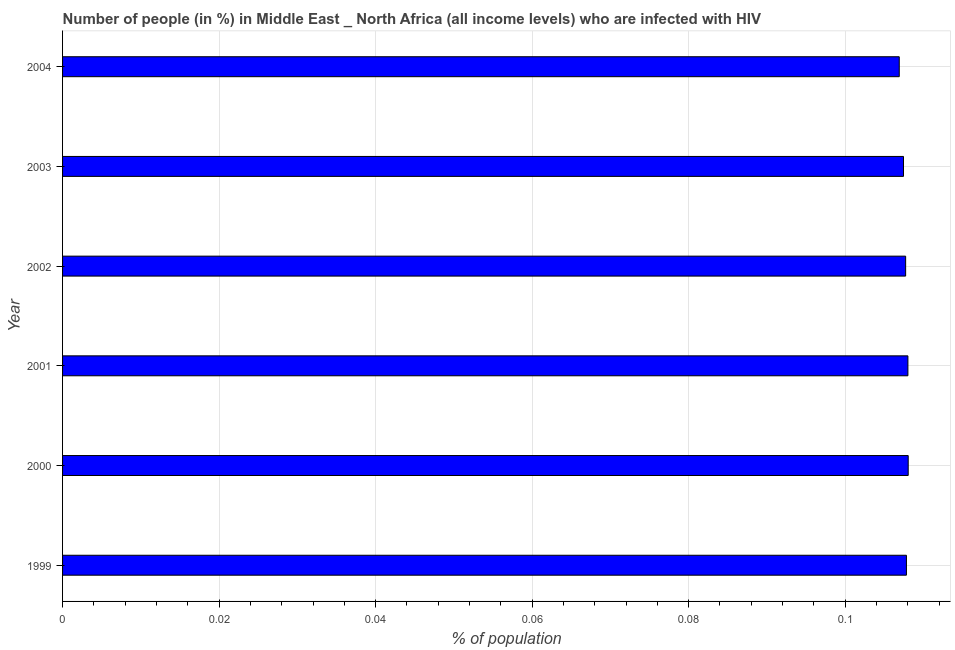Does the graph contain grids?
Offer a terse response. Yes. What is the title of the graph?
Ensure brevity in your answer.  Number of people (in %) in Middle East _ North Africa (all income levels) who are infected with HIV. What is the label or title of the X-axis?
Your response must be concise. % of population. What is the number of people infected with hiv in 2001?
Provide a short and direct response. 0.11. Across all years, what is the maximum number of people infected with hiv?
Your answer should be very brief. 0.11. Across all years, what is the minimum number of people infected with hiv?
Make the answer very short. 0.11. What is the sum of the number of people infected with hiv?
Make the answer very short. 0.65. What is the average number of people infected with hiv per year?
Keep it short and to the point. 0.11. What is the median number of people infected with hiv?
Provide a short and direct response. 0.11. In how many years, is the number of people infected with hiv greater than 0.06 %?
Provide a short and direct response. 6. What is the ratio of the number of people infected with hiv in 1999 to that in 2003?
Your answer should be very brief. 1. What is the difference between the highest and the second highest number of people infected with hiv?
Offer a terse response. 0. Is the sum of the number of people infected with hiv in 2001 and 2004 greater than the maximum number of people infected with hiv across all years?
Provide a short and direct response. Yes. In how many years, is the number of people infected with hiv greater than the average number of people infected with hiv taken over all years?
Offer a terse response. 4. How many bars are there?
Offer a very short reply. 6. How many years are there in the graph?
Ensure brevity in your answer.  6. What is the % of population of 1999?
Ensure brevity in your answer.  0.11. What is the % of population of 2000?
Provide a succinct answer. 0.11. What is the % of population of 2001?
Give a very brief answer. 0.11. What is the % of population in 2002?
Provide a succinct answer. 0.11. What is the % of population of 2003?
Offer a terse response. 0.11. What is the % of population of 2004?
Offer a terse response. 0.11. What is the difference between the % of population in 1999 and 2000?
Your response must be concise. -0. What is the difference between the % of population in 1999 and 2001?
Provide a short and direct response. -0. What is the difference between the % of population in 1999 and 2003?
Provide a succinct answer. 0. What is the difference between the % of population in 1999 and 2004?
Offer a terse response. 0. What is the difference between the % of population in 2000 and 2001?
Give a very brief answer. 4e-5. What is the difference between the % of population in 2000 and 2002?
Keep it short and to the point. 0. What is the difference between the % of population in 2000 and 2003?
Give a very brief answer. 0. What is the difference between the % of population in 2000 and 2004?
Offer a terse response. 0. What is the difference between the % of population in 2001 and 2002?
Give a very brief answer. 0. What is the difference between the % of population in 2001 and 2003?
Provide a succinct answer. 0. What is the difference between the % of population in 2001 and 2004?
Make the answer very short. 0. What is the difference between the % of population in 2002 and 2003?
Make the answer very short. 0. What is the difference between the % of population in 2002 and 2004?
Offer a very short reply. 0. What is the difference between the % of population in 2003 and 2004?
Offer a very short reply. 0. What is the ratio of the % of population in 1999 to that in 2000?
Your answer should be compact. 1. What is the ratio of the % of population in 1999 to that in 2003?
Ensure brevity in your answer.  1. What is the ratio of the % of population in 2000 to that in 2001?
Provide a short and direct response. 1. What is the ratio of the % of population in 2000 to that in 2002?
Ensure brevity in your answer.  1. What is the ratio of the % of population in 2000 to that in 2003?
Provide a short and direct response. 1.01. What is the ratio of the % of population in 2000 to that in 2004?
Offer a terse response. 1.01. What is the ratio of the % of population in 2003 to that in 2004?
Your answer should be compact. 1. 